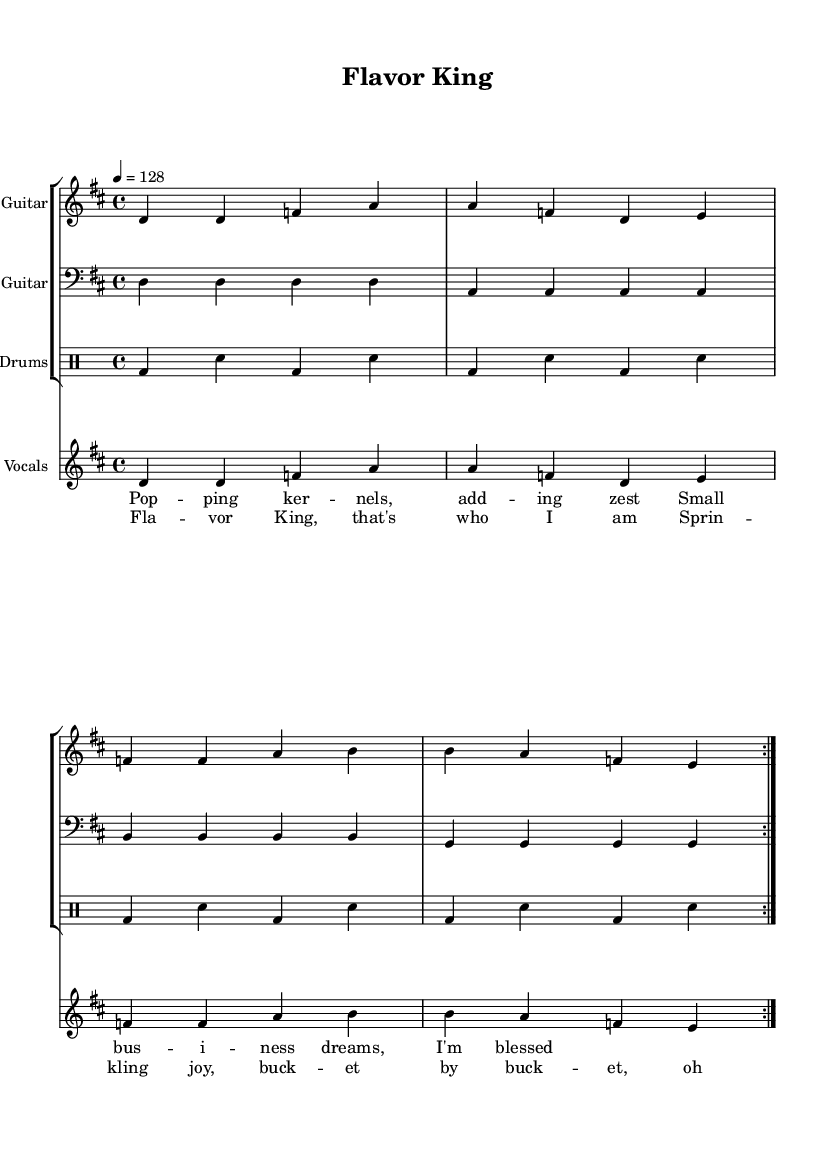What is the key signature of this music? The key signature is D major, which has two sharps (F# and C#).
Answer: D major What is the time signature of this music? The time signature is 4/4, which means there are four beats in a measure.
Answer: 4/4 What is the tempo marking for this piece? The tempo marking is 128 beats per minute, indicated by the notation "4 = 128".
Answer: 128 beats per minute How many measures are repeated in the score? The score indicates that there are two measures that are repeated, marked by "volta 2".
Answer: 2 What instrument plays the highest pitch in the score? The electric guitar plays the highest pitch in the score, as it covers a range from D4 to B5.
Answer: Electric Guitar What lyrics accompany the chorus section? The lyrics for the chorus are "Flavor King, that's who I am, Sprinkling joy, bucket by bucket, oh man!"
Answer: "Flavor King, that's who I am, Sprinkling joy, bucket by bucket, oh man!" Which part of the arrangement features the drums? The drums part is indicated as "Drums" in the staff grouping, specifically part of the percussion section written in a drum mode.
Answer: Drums 